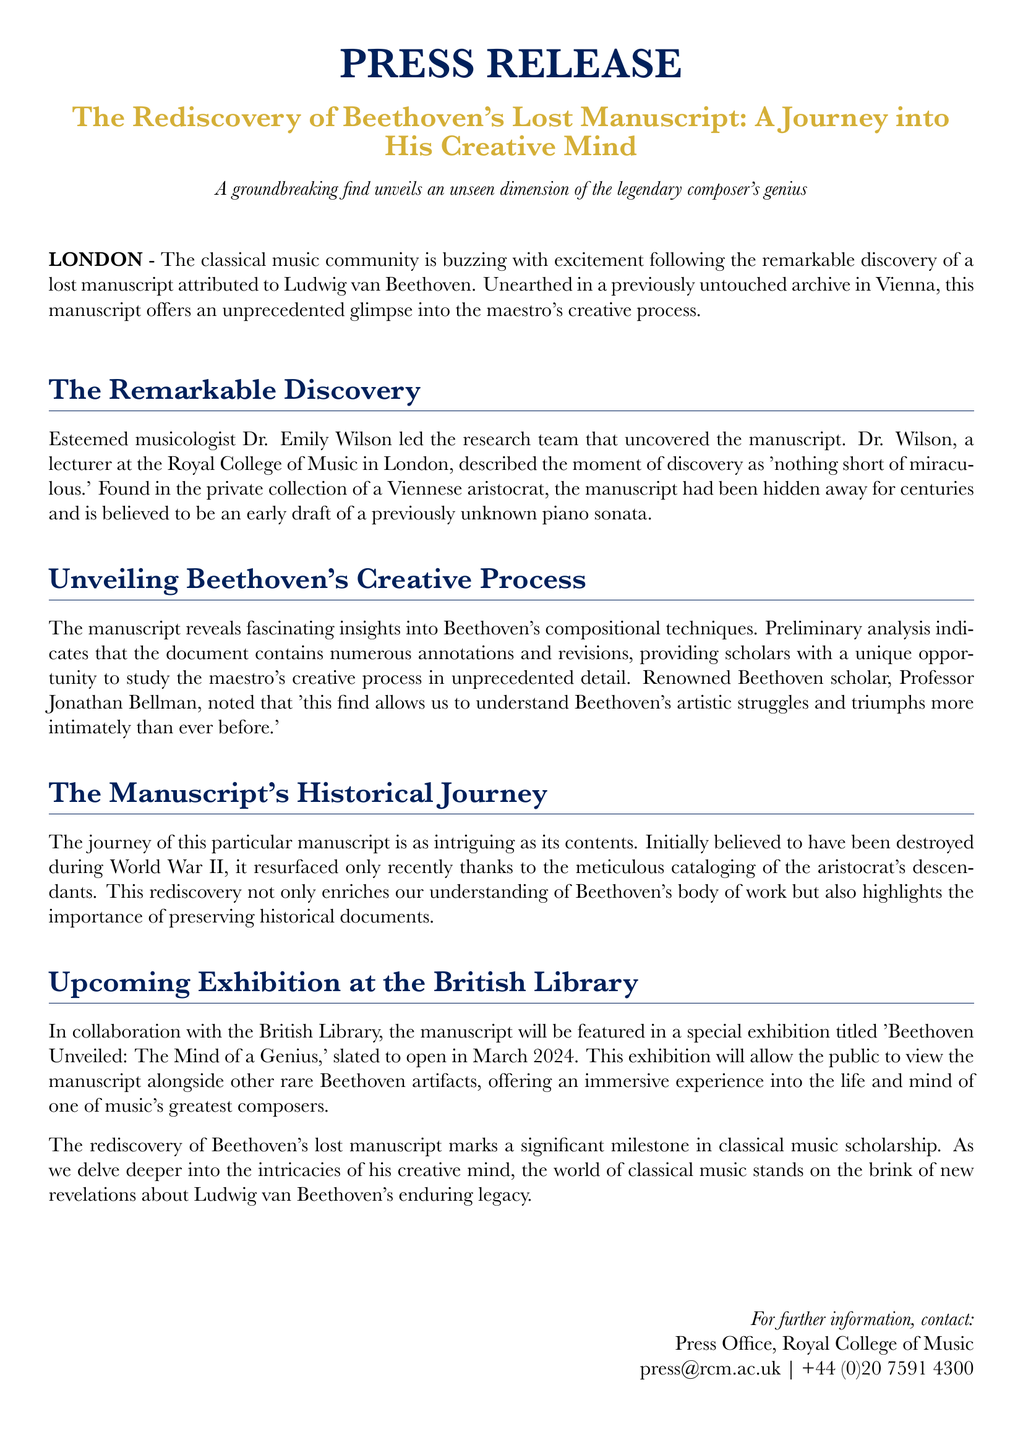What is the title of the manuscript? The title of the manuscript is described in the press release as an early draft of a previously unknown piano sonata.
Answer: previously unknown piano sonata Who led the research team that uncovered the manuscript? The press release mentions that esteemed musicologist Dr. Emily Wilson led the research team.
Answer: Dr. Emily Wilson When is the exhibition 'Beethoven Unveiled: The Mind of a Genius' slated to open? The exhibition's opening date is specifically stated in the document as March 2024.
Answer: March 2024 What did Professor Jonathan Bellman note about the find? The press release cites Professor Jonathan Bellman noting that this find allows for an intimate understanding of Beethoven's artistic struggles and triumphs.
Answer: intimate understanding Where was the manuscript discovered? The document states that the manuscript was unearthed in a previously untouched archive in Vienna.
Answer: Vienna What historical event was initially believed to have destroyed the manuscript? The press release indicates that the manuscript was initially believed to have been destroyed during World War II.
Answer: World War II What is the purpose of the exhibition in collaboration with the British Library? The purpose of the exhibition is to allow the public to view the manuscript alongside rare Beethoven artifacts.
Answer: public viewing What is the color theme used in the press release? The press release uses a specific color theme defined in the document, with notable colors being beethovenblue and goldaccent.
Answer: beethovenblue and goldaccent 